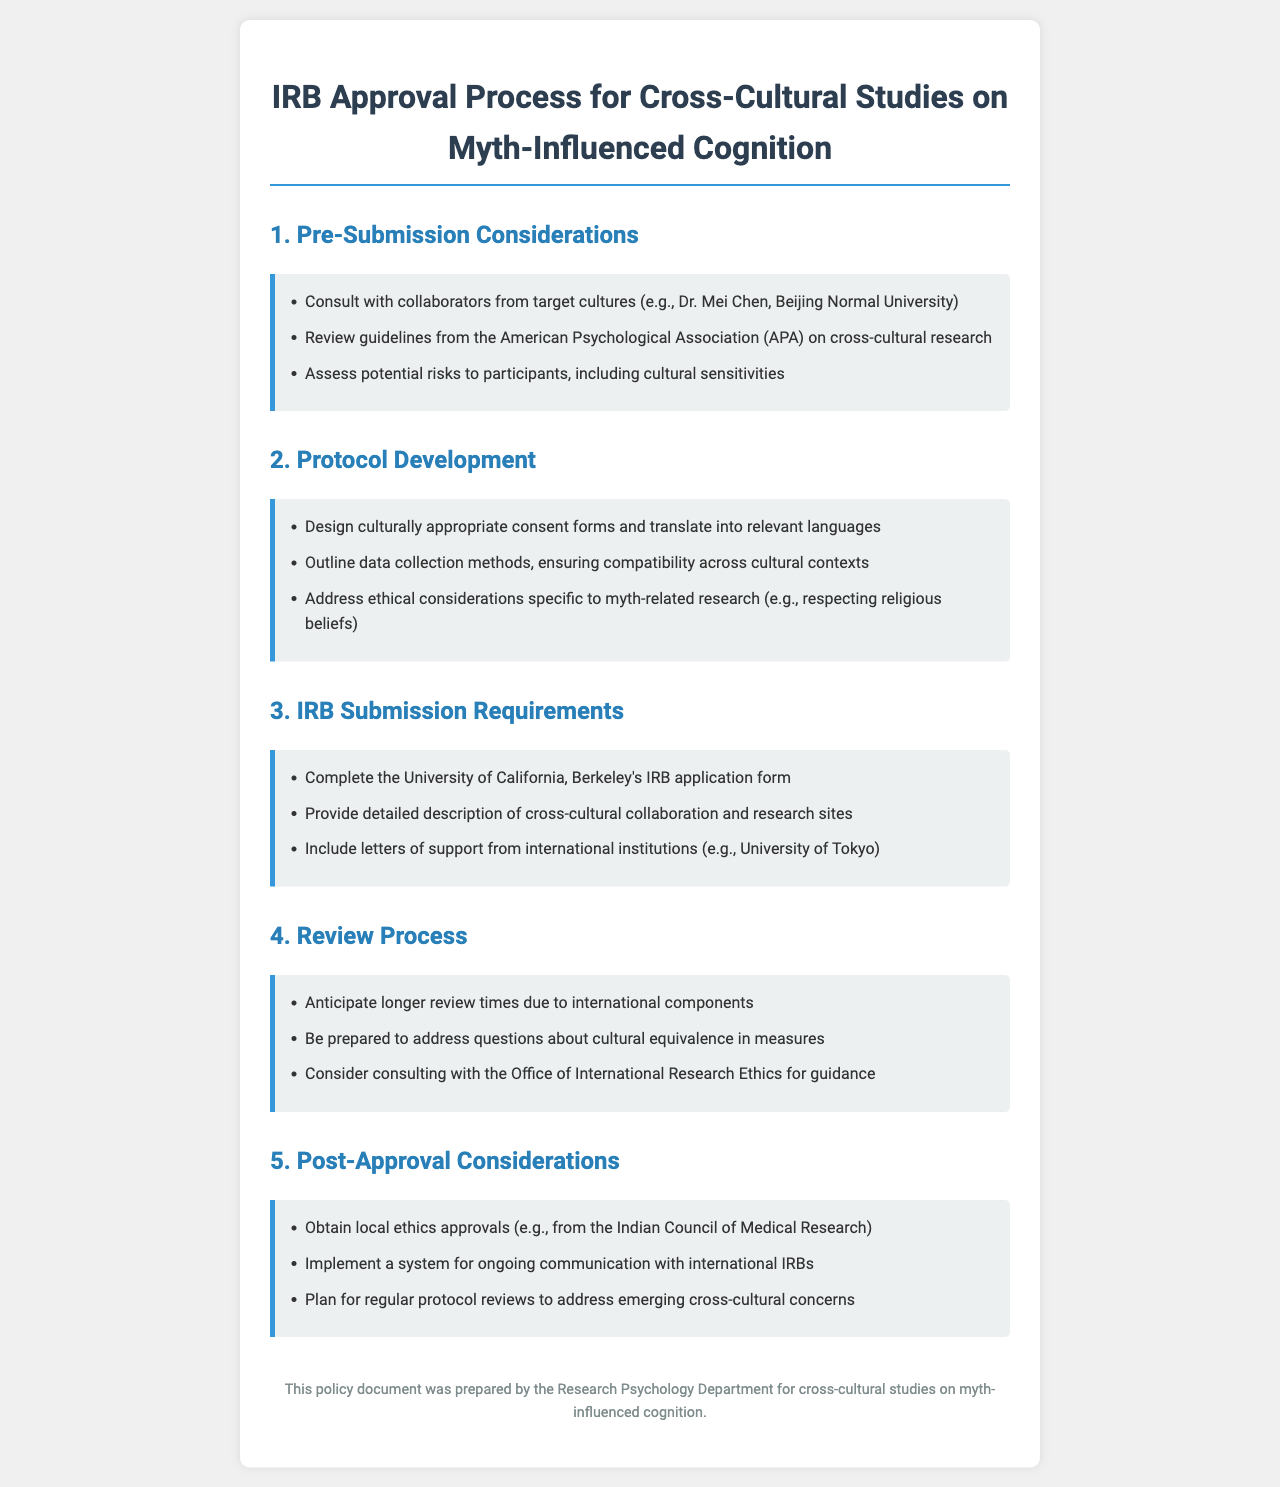What is the title of the document? The title of the document is provided at the beginning, which is "IRB Approval Process for Cross-Cultural Studies on Myth-Influenced Cognition."
Answer: IRB Approval Process for Cross-Cultural Studies on Myth-Influenced Cognition Who should collaborators consult with during pre-submission? The document specifies that collaborators should consult with individuals from target cultures, for example, Dr. Mei Chen from Beijing Normal University.
Answer: Dr. Mei Chen What is required in the protocol development section? The protocol development section includes designing culturally appropriate consent forms and translating them into relevant languages as a key requirement.
Answer: Culturally appropriate consent forms What is one of the post-approval considerations listed? The post-approval considerations include obtaining local ethics approvals, such as those from the Indian Council of Medical Research.
Answer: Local ethics approvals How many sections are included in the document? The document contains five main sections outlining different aspects of the IRB approval process.
Answer: Five What should researchers be prepared to address during the review process? The document mentions that researchers should be prepared to address questions about cultural equivalence in measures during the review process.
Answer: Cultural equivalence in measures Which office can researchers consult for guidance? Researchers are advised to consider consulting with the Office of International Research Ethics for guidance as noted in the review process section.
Answer: Office of International Research Ethics What type of approvals must be obtained post-approval? The document states that local ethics approvals must be obtained after the IRB approval process.
Answer: Local ethics approvals What organization’s guidelines should be reviewed in pre-submission considerations? In the pre-submission considerations, it is mentioned that researchers should review guidelines from the American Psychological Association (APA).
Answer: American Psychological Association (APA) 